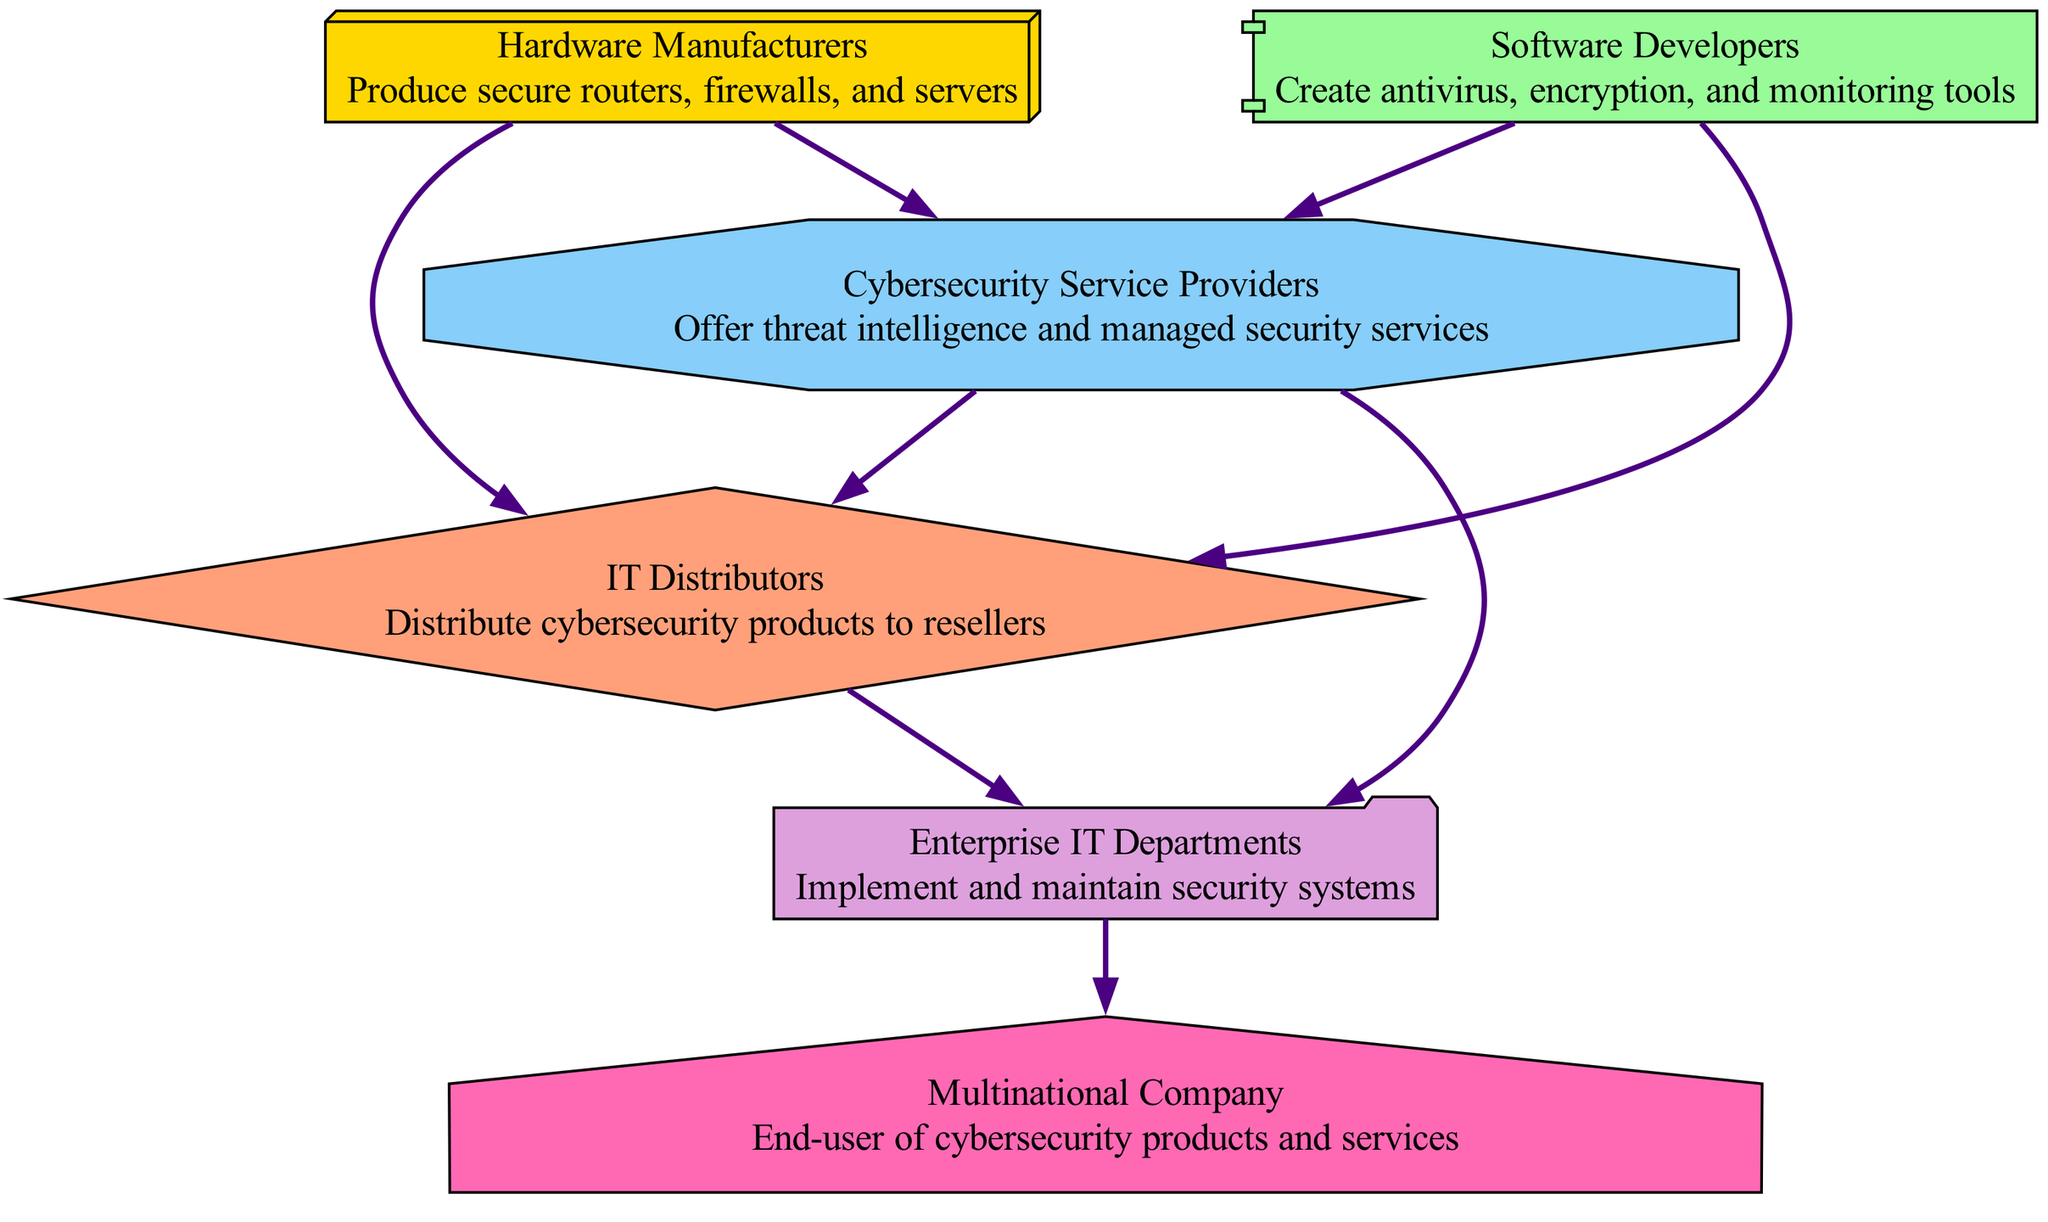What is the first node in the supply chain? The first node in the supply chain diagram is "Hardware Manufacturers". It is positioned at the top, indicating it is the starting point that produces essential hardware products.
Answer: Hardware Manufacturers How many nodes are there in the diagram? The diagram contains a total of six nodes: Hardware Manufacturers, Software Developers, Cybersecurity Service Providers, IT Distributors, Enterprise IT Departments, and Multinational Company.
Answer: 6 Which node consumes from both Hardware Manufacturers and Software Developers? The node "Cybersecurity Service Providers" consumes products and services from both hardware and software sources as it relies on secure hardware and developed software to provide security services.
Answer: Cybersecurity Service Providers What is the relationship between IT Distributors and Cybersecurity Service Providers? IT Distributors receive products and services from Cybersecurity Service Providers, as they distribute these cybersecurity solutions to resellers, making this a downstream relationship.
Answer: Downstream How many edges are directed towards the Multinational Company? There is one directed edge towards the Multinational Company from the Enterprise IT Departments, indicating that they implement and maintain cybersecurity systems before the company consumes these services.
Answer: 1 Which node is at the end of the supply chain? The node positioned at the end of the supply chain is the "Multinational Company" as it finalizes the consumption of cybersecurity products and services delivered through the supply chain.
Answer: Multinational Company What type of products do Software Developers create? Software Developers create "antivirus, encryption, and monitoring tools", which are integral components of cybersecurity services as they provide essential software security.
Answer: Antivirus, encryption, and monitoring tools Who ultimately consumes the services from the Enterprise IT Departments? The ultimate consumer of the services that come from the Enterprise IT Departments is the "Multinational Company", which utilizes these security systems to protect its operations.
Answer: Multinational Company 